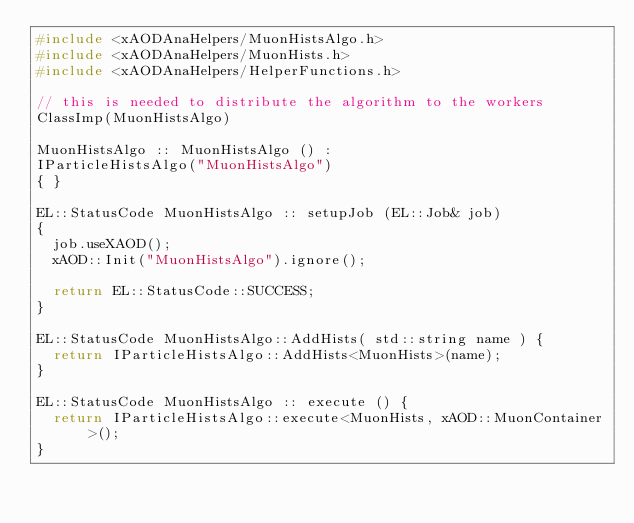Convert code to text. <code><loc_0><loc_0><loc_500><loc_500><_C++_>#include <xAODAnaHelpers/MuonHistsAlgo.h>
#include <xAODAnaHelpers/MuonHists.h>
#include <xAODAnaHelpers/HelperFunctions.h>

// this is needed to distribute the algorithm to the workers
ClassImp(MuonHistsAlgo)

MuonHistsAlgo :: MuonHistsAlgo () :
IParticleHistsAlgo("MuonHistsAlgo")
{ }

EL::StatusCode MuonHistsAlgo :: setupJob (EL::Job& job)
{
  job.useXAOD();
  xAOD::Init("MuonHistsAlgo").ignore();

  return EL::StatusCode::SUCCESS;
}

EL::StatusCode MuonHistsAlgo::AddHists( std::string name ) {
  return IParticleHistsAlgo::AddHists<MuonHists>(name);
}

EL::StatusCode MuonHistsAlgo :: execute () {
  return IParticleHistsAlgo::execute<MuonHists, xAOD::MuonContainer>();
}
</code> 